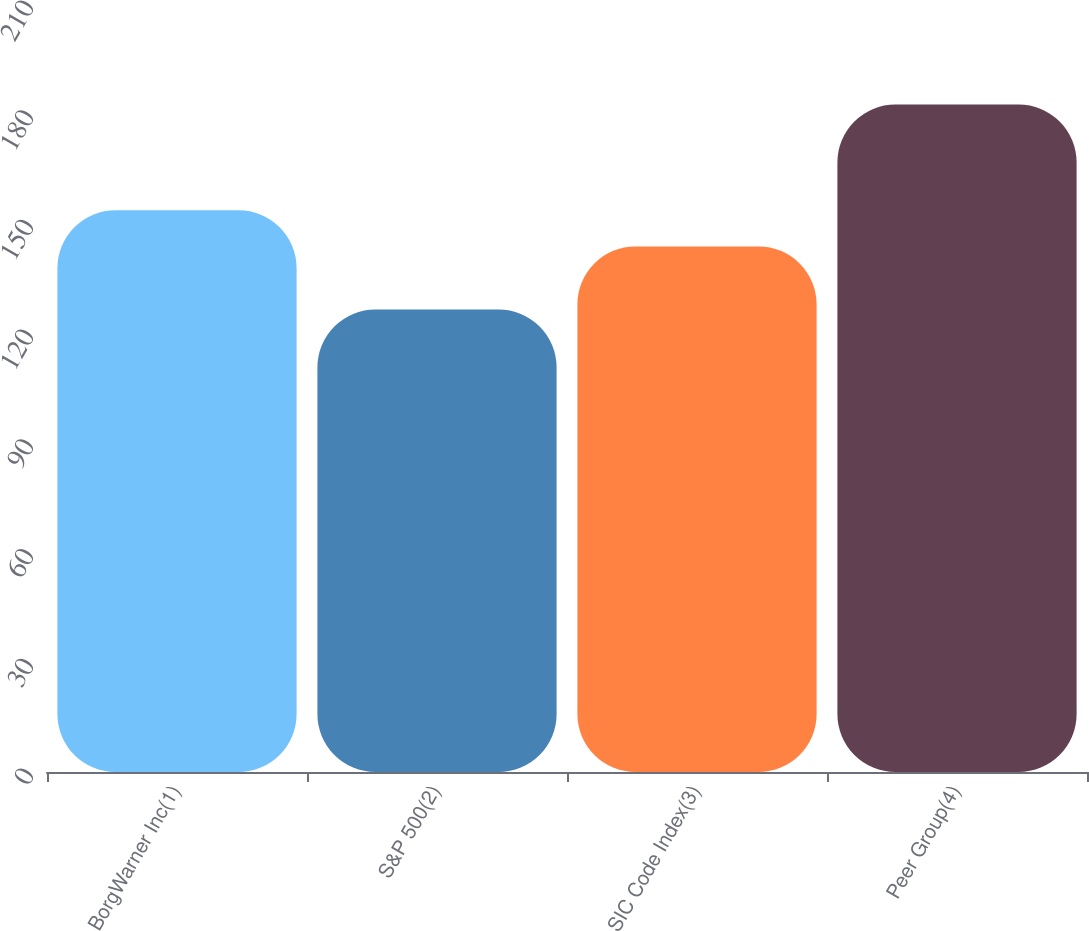<chart> <loc_0><loc_0><loc_500><loc_500><bar_chart><fcel>BorgWarner Inc(1)<fcel>S&P 500(2)<fcel>SIC Code Index(3)<fcel>Peer Group(4)<nl><fcel>153.61<fcel>126.46<fcel>143.71<fcel>182.52<nl></chart> 